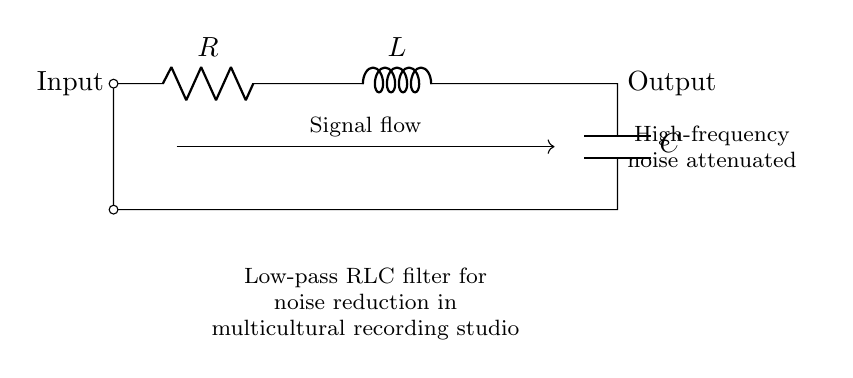What is the purpose of this circuit? The circuit is designed as a low-pass RLC filter intended to reduce high-frequency noise, which is particularly useful in a recording studio to maintain sound quality.
Answer: Noise reduction What components are present in this circuit? The circuit consists of a resistor, an inductor, and a capacitor. Each component plays a role in filtering the signals.
Answer: Resistor, inductor, capacitor What happens to high-frequency signals in this filter? High-frequency signals are attenuated or reduced. This means they lose strength when passing through the circuit.
Answer: Attenuated How does the low-pass filter behave at low frequencies? At low frequencies, the filter allows signals to pass through with little resistance or attenuation, enabling low-frequency sounds to be captured clearly.
Answer: Pass-through Where do the input and output connections occur in the circuit? The input connection is located at the left side of the circuit, while the output connection is at the right side. This indicates the direction of signal flow.
Answer: Input left, output right What is the overall effect of using an RLC filter in a recording studio? The overall effect is improved sound quality by minimizing unwanted high-frequency noise, leading to a clearer recording.
Answer: Improved sound quality 